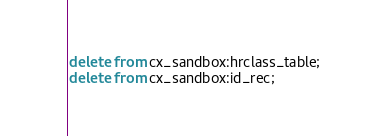<code> <loc_0><loc_0><loc_500><loc_500><_SQL_>delete from cx_sandbox:hrclass_table;
delete from cx_sandbox:id_rec;

</code> 